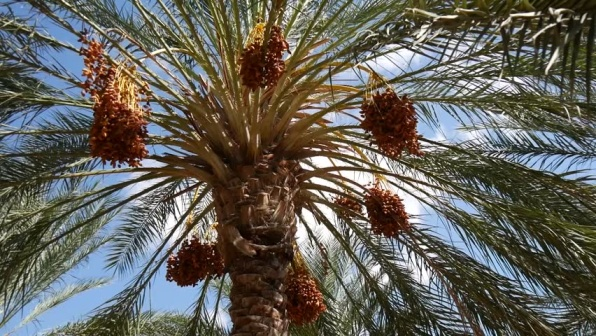Can you tell me what kind of palm tree this is and what region it might be native to? This appears to be a date palm, scientifically known as Phoenix dactylifera. It is native to regions of North Africa, the Middle East, and South Asia. This palm species is highly prized for its sweet fruit, dates, and has been cultivated for thousands of years in these regions, thriving in arid conditions. 